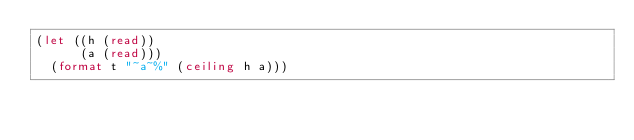<code> <loc_0><loc_0><loc_500><loc_500><_Lisp_>(let ((h (read))
      (a (read)))
  (format t "~a~%" (ceiling h a)))</code> 